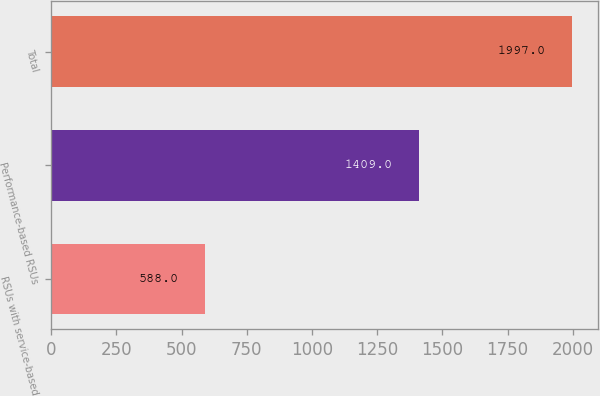<chart> <loc_0><loc_0><loc_500><loc_500><bar_chart><fcel>RSUs with service-based<fcel>Performance-based RSUs<fcel>Total<nl><fcel>588<fcel>1409<fcel>1997<nl></chart> 